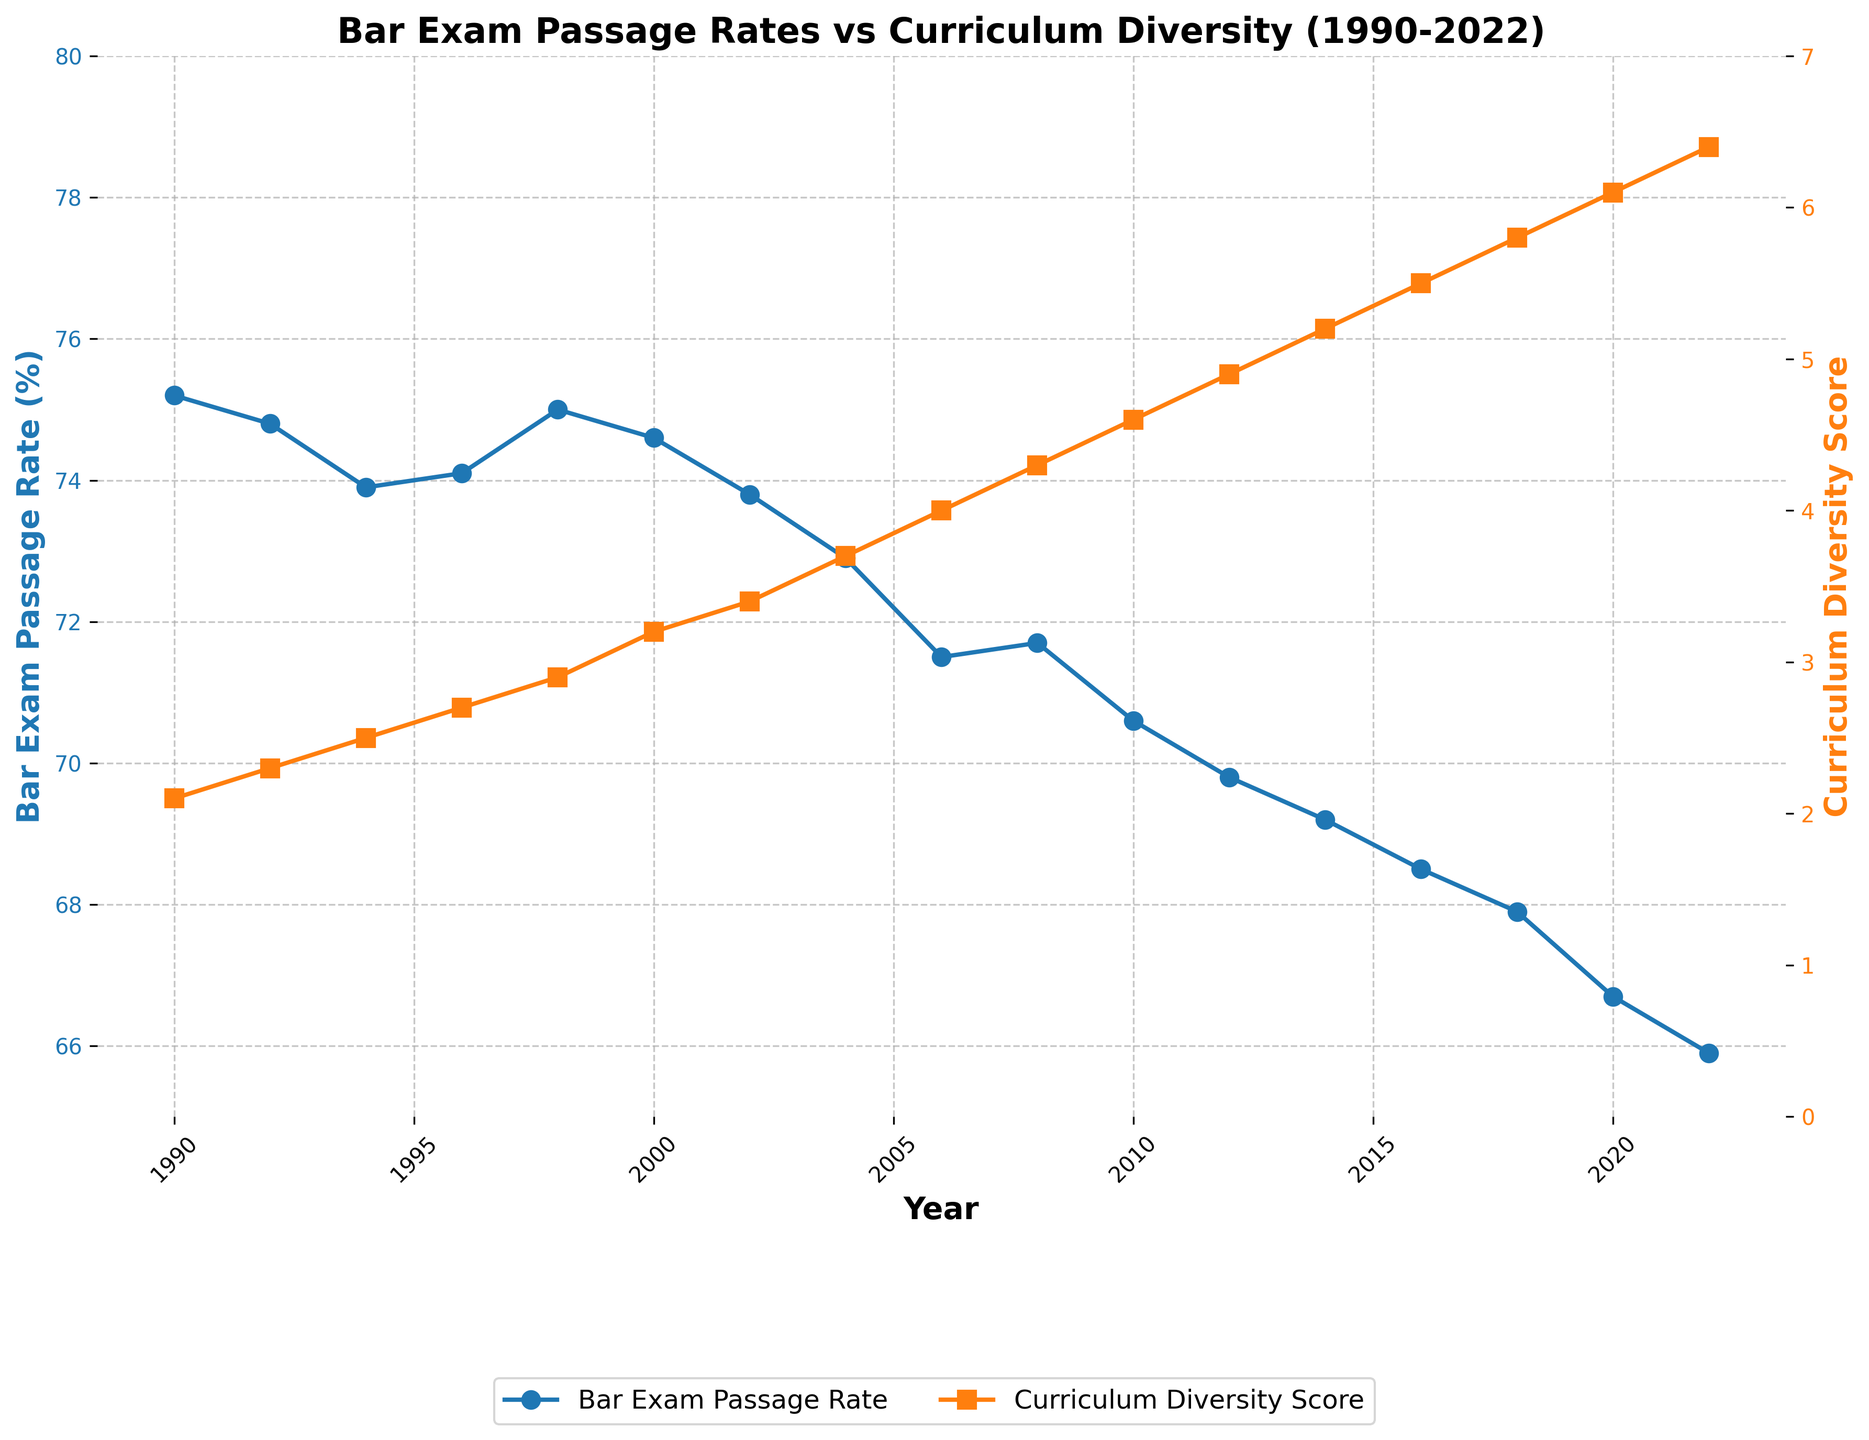What general trend is observed for the Bar Exam Passage Rate from 1990 to 2022? The line representing the Bar Exam Passage Rate shows a downward trend from 1990 to 2022. Initially, rates were around 75%, but steadily declined to below 67% by 2022.
Answer: Downward trend How did the Curriculum Diversity Score change from 2000 to 2022? The line representing the Curriculum Diversity Score shows an upward trend from 2000 to 2022. Starting around 3.2 in 2000, it increased to approximately 6.4 by 2022.
Answer: Upward trend In which year was the Bar Exam Passage Rate higher: 1994 or 2014? To compare, check the passage rate values for both years on the chart. In 1994, it was about 73.9%, whereas in 2014, it was around 69.2%.
Answer: 1994 What is the difference in Curriculum Diversity Score between 1996 and 2006? The Curriculum Diversity Score in 1996 was 2.7 and in 2006 it was 4.0. Calculate the difference 4.0 - 2.7.
Answer: 1.3 How many years did it take for the Bar Exam Passage Rate to drop below 70% from its value in 1990? In 1990, the rate was 75.2%. It first dropped below 70% in 2012 when it reached 69.8%. Calculate 2012 - 1990.
Answer: 22 years Which years had a Bar Exam Passage Rate below 70%? Identify the years where the passage rate was below 70%. These years are 2012, 2014, 2016, 2018, 2020, and 2022.
Answer: 2012, 2014, 2016, 2018, 2020, 2022 Which data series uses a line with a color that is typically associated with warmth? The Curriculum Diversity Score is represented by a line in orange, which is a warm color.
Answer: Curriculum Diversity Score What was the average Curriculum Diversity Score for the years 2000, 2006, 2012, and 2018? Find the scores for the specified years: 2000 (3.2), 2006 (4.0), 2012 (4.9), and 2018 (5.8). Sum these scores and divide by 4. (3.2 + 4.0 + 4.9 + 5.8) / 4 = 17.9 / 4.
Answer: 4.475 In which year did the Bar Exam Passage Rate and Curriculum Diversity Score intersect in their respective trends? The chart shows no intersection points, as their lines do not cross.
Answer: No intersection How much did the Bar Exam Passage Rate decrease from 1990 to 2022? The rate in 1990 was 75.2%, and it decreased to 65.9% in 2022. Subtract the two: 75.2 - 65.9.
Answer: 9.3% 